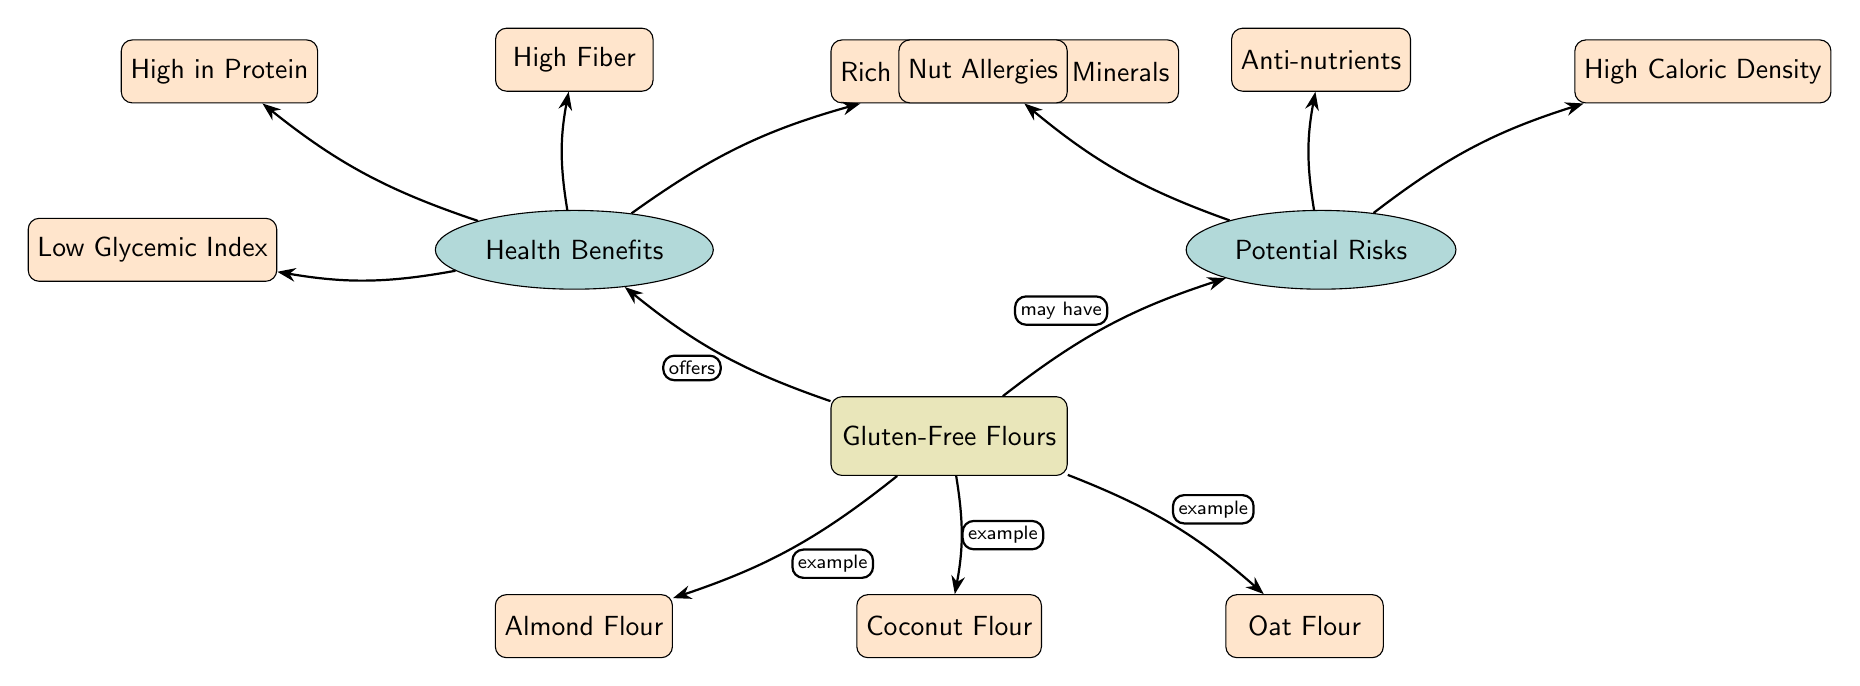What are three examples of gluten-free flours mentioned in the diagram? The diagram lists Almond Flour, Coconut Flour, and Oat Flour as examples of gluten-free flours located below the main node 'Gluten-Free Flours'.
Answer: Almond Flour, Coconut Flour, Oat Flour What is a health benefit related to gluten-free flours? The health benefits mentioned in the diagram include High in Protein, High Fiber, Rich in Vitamins & Minerals, and Low Glycemic Index which are nodes connected to the category 'Health Benefits'.
Answer: High in Protein How many potential risks are associated with gluten-free flours? The diagram specifies three potential risks: Nut Allergies, Anti-nutrients, and High Caloric Density under the category 'Potential Risks'. Therefore, the count of potential risks is three.
Answer: Three What type of relationship exists between gluten-free flours and health benefits? The diagram indicates that gluten-free flours 'offers' health benefits through the directed edge leading from 'Gluten-Free Flours' to 'Health Benefits'.
Answer: offers Which gluten-free flour is associated with nut allergies? Nut Allergies, categorized under 'Potential Risks', is not directly associated with any specific gluten-free flour, but it can be inferred to relate to Almond Flour, as it is a nut-based flour.
Answer: Almond Flour What characteristic connects High Fiber and Low Glycemic Index in the diagram? Both High Fiber and Low Glycemic Index are listed under the category of 'Health Benefits', indicating they share a common characteristic of being beneficial properties associated with gluten-free flours.
Answer: Health Benefits What is the relationship between gluten-free flours and potential risks? The diagram shows that gluten-free flours 'may have' associated potential risks, indicated through the edge from 'Gluten-Free Flours' to the category 'Potential Risks'.
Answer: may have What benefits does coconut flour specifically fall under in the diagram? Coconut Flour is listed as an example of gluten-free flour, which is linked to the category 'Health Benefits' that includes various beneficial attributes but does not specify the individual benefits of coconut flour.
Answer: Health Benefits 